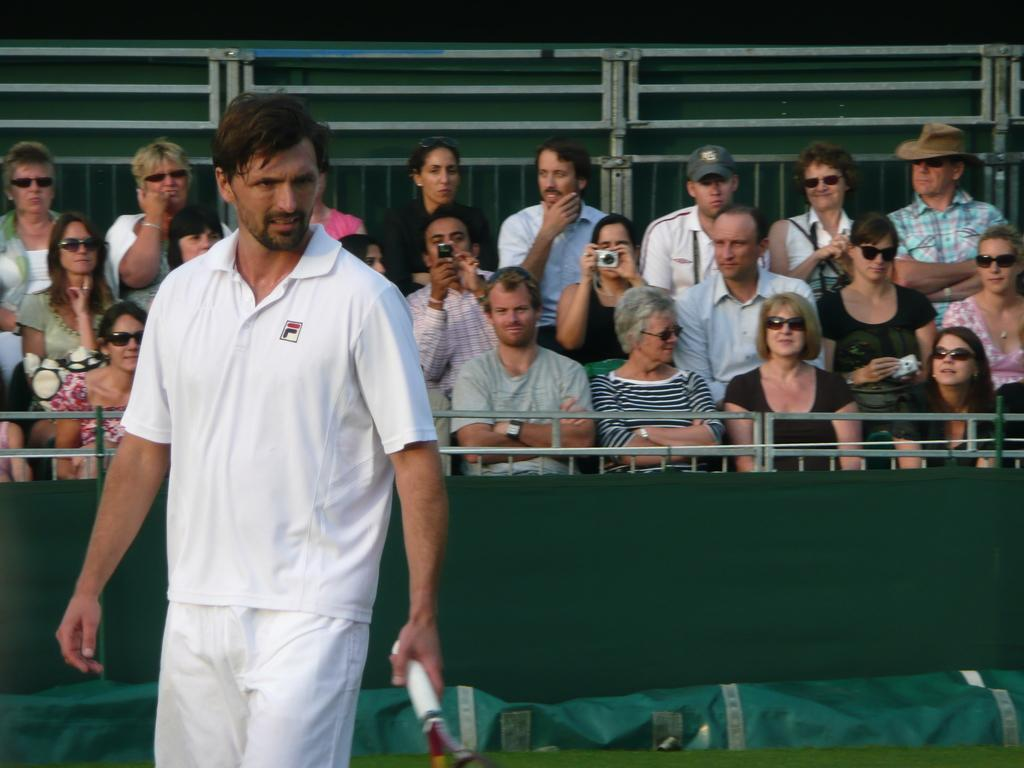What is the man in the image holding? The man is holding a tennis racket. What can be seen in the background of the image? There are people sitting in the background of the image. What is covering the ground in the image? There is a green sheet on the ground in the image. What type of bell can be heard ringing in the image? There is no bell present in the image, so it cannot be heard ringing. 